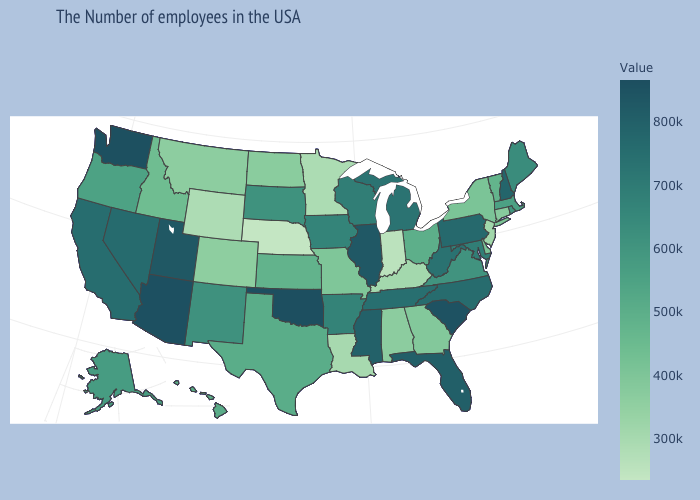Does Montana have a higher value than North Carolina?
Concise answer only. No. Which states have the lowest value in the MidWest?
Keep it brief. Nebraska. Does Illinois have the highest value in the MidWest?
Short answer required. Yes. Among the states that border Maine , which have the highest value?
Concise answer only. New Hampshire. Among the states that border Kentucky , does Indiana have the lowest value?
Write a very short answer. Yes. Which states hav the highest value in the West?
Keep it brief. Washington. Does Washington have the highest value in the West?
Answer briefly. Yes. Does Oklahoma have the highest value in the USA?
Be succinct. Yes. Which states have the lowest value in the MidWest?
Keep it brief. Nebraska. 